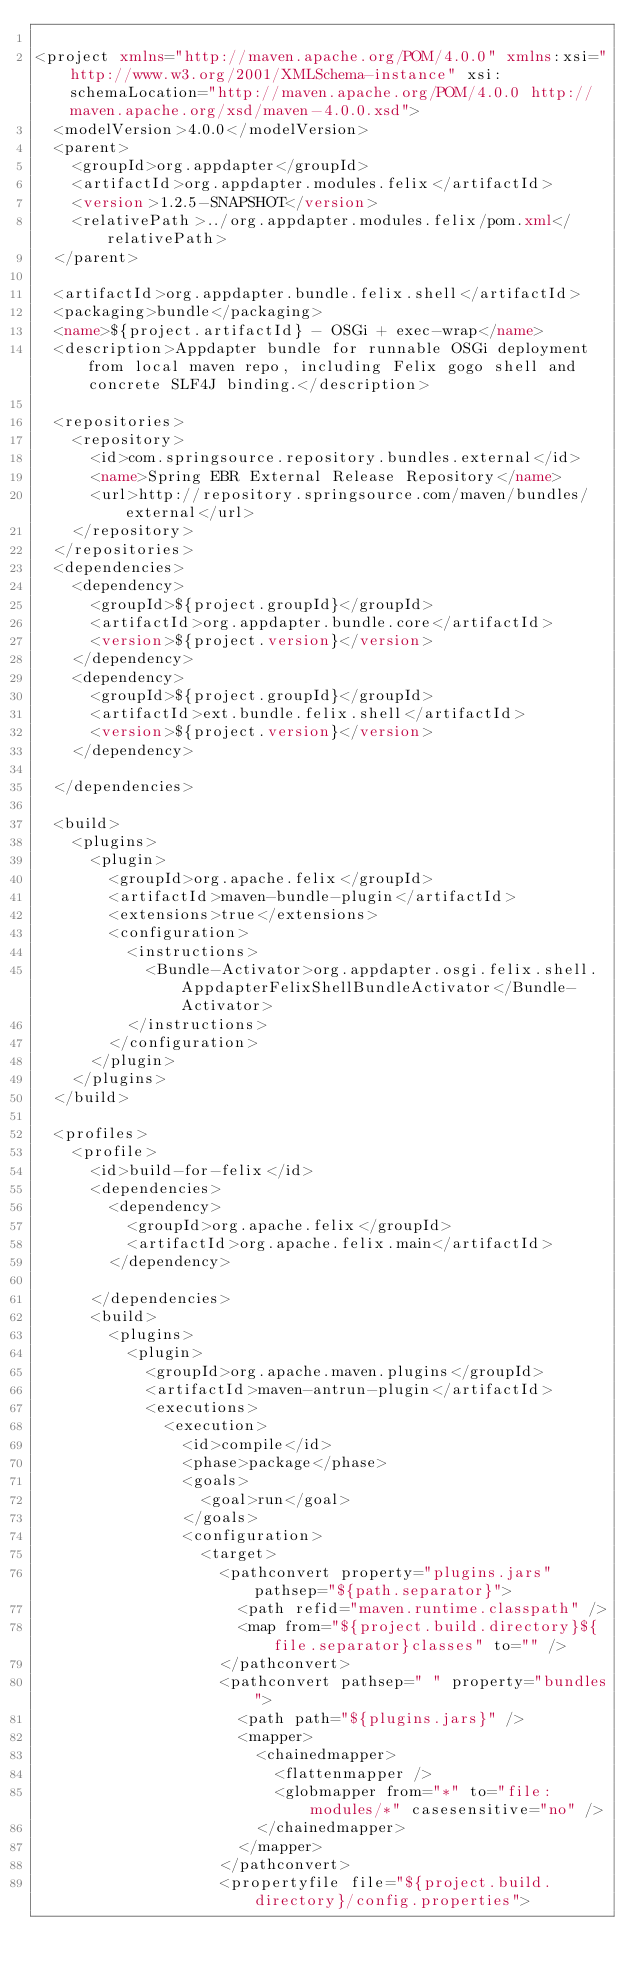Convert code to text. <code><loc_0><loc_0><loc_500><loc_500><_XML_>
<project xmlns="http://maven.apache.org/POM/4.0.0" xmlns:xsi="http://www.w3.org/2001/XMLSchema-instance" xsi:schemaLocation="http://maven.apache.org/POM/4.0.0 http://maven.apache.org/xsd/maven-4.0.0.xsd">
	<modelVersion>4.0.0</modelVersion>
	<parent>
		<groupId>org.appdapter</groupId>
		<artifactId>org.appdapter.modules.felix</artifactId>
		<version>1.2.5-SNAPSHOT</version>
		<relativePath>../org.appdapter.modules.felix/pom.xml</relativePath>
	</parent>

	<artifactId>org.appdapter.bundle.felix.shell</artifactId>	
	<packaging>bundle</packaging>
	<name>${project.artifactId} - OSGi + exec-wrap</name>
	<description>Appdapter bundle for runnable OSGi deployment from local maven repo, including Felix gogo shell and concrete SLF4J binding.</description>

	<repositories>
		<repository>
			<id>com.springsource.repository.bundles.external</id>
			<name>Spring EBR External Release Repository</name>
			<url>http://repository.springsource.com/maven/bundles/external</url>
		</repository>		
	</repositories>
	<dependencies>
		<dependency>
			<groupId>${project.groupId}</groupId>
			<artifactId>org.appdapter.bundle.core</artifactId>
			<version>${project.version}</version>
		</dependency>
		<dependency>
			<groupId>${project.groupId}</groupId>
			<artifactId>ext.bundle.felix.shell</artifactId>
			<version>${project.version}</version>
		</dependency>
	
	</dependencies>

	<build>
		<plugins>
			<plugin>
				<groupId>org.apache.felix</groupId>
				<artifactId>maven-bundle-plugin</artifactId>
				<extensions>true</extensions>
				<configuration>
					<instructions>
						<Bundle-Activator>org.appdapter.osgi.felix.shell.AppdapterFelixShellBundleActivator</Bundle-Activator>
					</instructions>
				</configuration>
			</plugin>
		</plugins>
	</build>

	<profiles>
		<profile>
			<id>build-for-felix</id>
			<dependencies>
				<dependency>
					<groupId>org.apache.felix</groupId>
					<artifactId>org.apache.felix.main</artifactId>
				</dependency>

			</dependencies>
			<build>
				<plugins>
					<plugin>
						<groupId>org.apache.maven.plugins</groupId>
						<artifactId>maven-antrun-plugin</artifactId>
						<executions>
							<execution>
								<id>compile</id>
								<phase>package</phase>
								<goals>
									<goal>run</goal>
								</goals>
								<configuration>
									<target>
										<pathconvert property="plugins.jars" pathsep="${path.separator}">
											<path refid="maven.runtime.classpath" />
											<map from="${project.build.directory}${file.separator}classes" to="" />
										</pathconvert>
										<pathconvert pathsep=" " property="bundles">
											<path path="${plugins.jars}" />
											<mapper>
												<chainedmapper>
													<flattenmapper />
													<globmapper from="*" to="file:modules/*" casesensitive="no" />
												</chainedmapper>
											</mapper>
										</pathconvert>
										<propertyfile file="${project.build.directory}/config.properties"></code> 